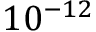Convert formula to latex. <formula><loc_0><loc_0><loc_500><loc_500>1 0 ^ { - 1 2 }</formula> 